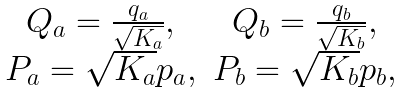Convert formula to latex. <formula><loc_0><loc_0><loc_500><loc_500>\begin{array} { c c } Q _ { a } = \frac { q _ { a } } { \sqrt { K _ { a } } } , & Q _ { b } = \frac { q _ { b } } { \sqrt { K _ { b } } } , \\ P _ { a } = \sqrt { K _ { a } } p _ { a } , & P _ { b } = \sqrt { K _ { b } } p _ { b } , \end{array}</formula> 